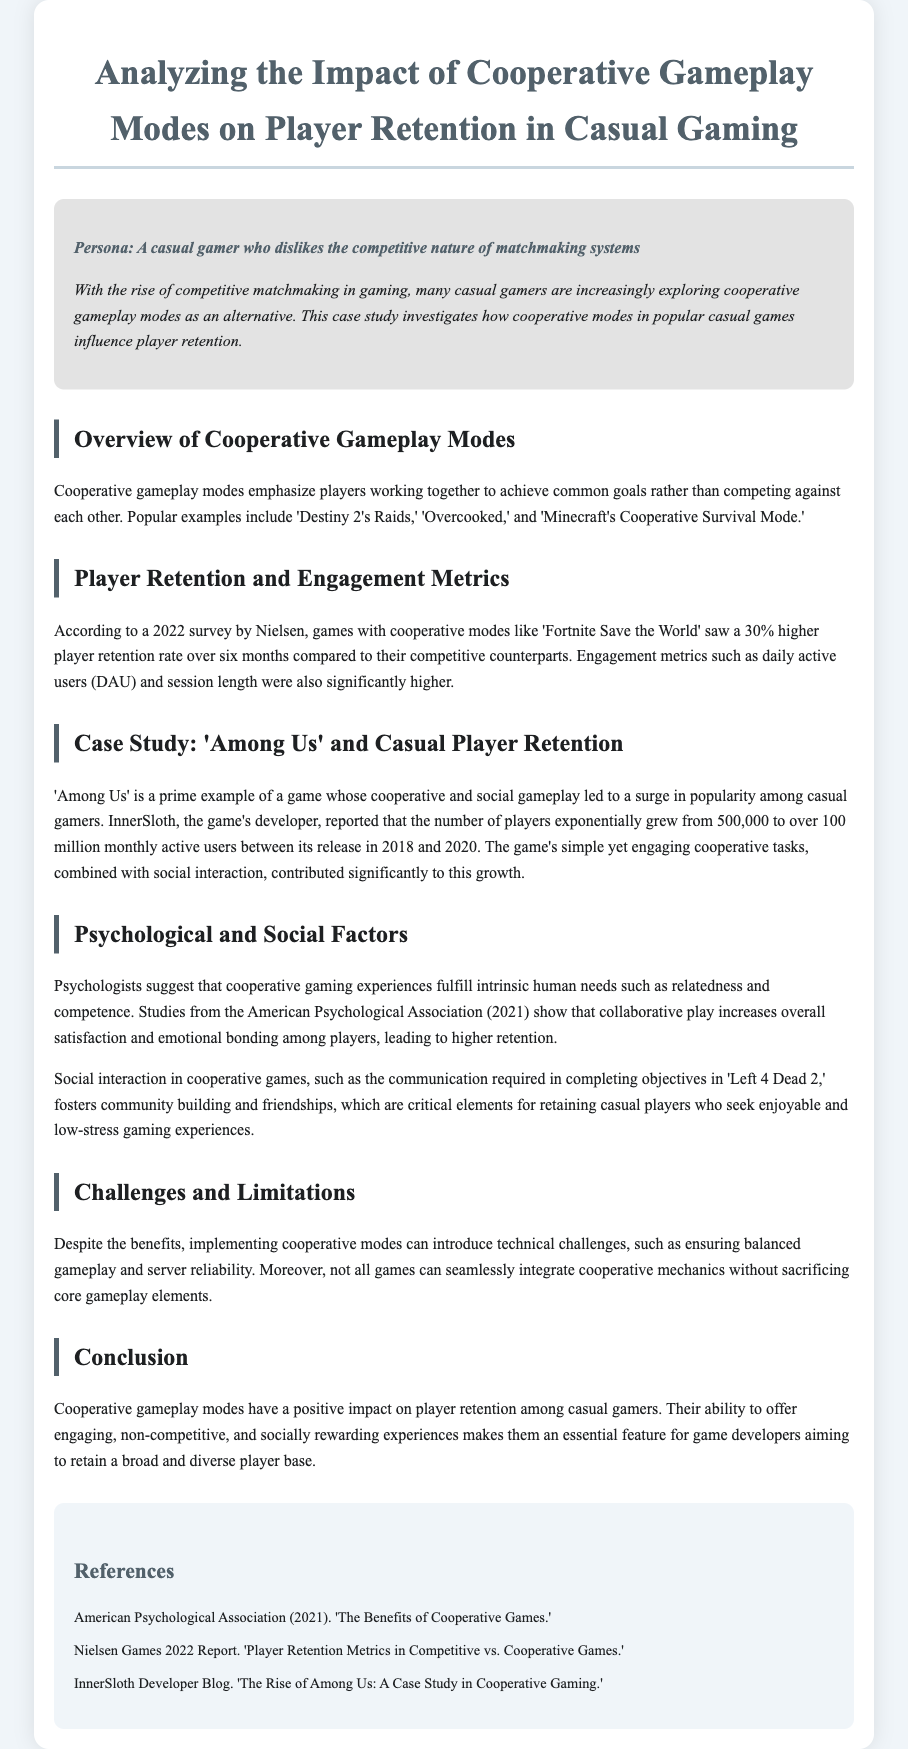What is the title of the case study? The title of the case study is stated at the top of the document, which is "Analyzing the Impact of Cooperative Gameplay Modes on Player Retention in Casual Gaming."
Answer: Analyzing the Impact of Cooperative Gameplay Modes on Player Retention in Casual Gaming What percentage higher is player retention for cooperative games compared to competitive games? The document cites a specific statistic from a survey indicating that games with cooperative modes saw a 30% higher player retention rate over six months.
Answer: 30% What is a prime example of a game that has seen popularity due to cooperative gameplay? The case study highlights "Among Us" as a prime example of a game whose cooperative gameplay led to a significant increase in player numbers.
Answer: Among Us What is one psychological benefit of cooperative gaming mentioned in the document? The document states that cooperative gaming experiences fulfill intrinsic human needs such as relatedness and competence, according to psychological studies.
Answer: Relatedness What was the growth in monthly active users for 'Among Us' from 2018 to 2020? The document provides information on the exponential growth of 'Among Us,' stating it grew from 500,000 to over 100 million monthly active users.
Answer: Over 100 million What technical challenges are associated with cooperative gameplay modes? The document mentions technical challenges such as ensuring balanced gameplay and server reliability as complications that can arise from implementing cooperative modes.
Answer: Balanced gameplay What are some examples of popular cooperative gameplay modes? The document lists 'Destiny 2's Raids,' 'Overcooked,' and 'Minecraft's Cooperative Survival Mode' as examples of cooperative gameplay modes.
Answer: Destiny 2's Raids, Overcooked, Minecraft's Cooperative Survival Mode Which organization conducted a survey mentioned in the case study? The Nielsen Games 2022 Report is referenced as the source of the survey that provides player retention metrics.
Answer: Nielsen 